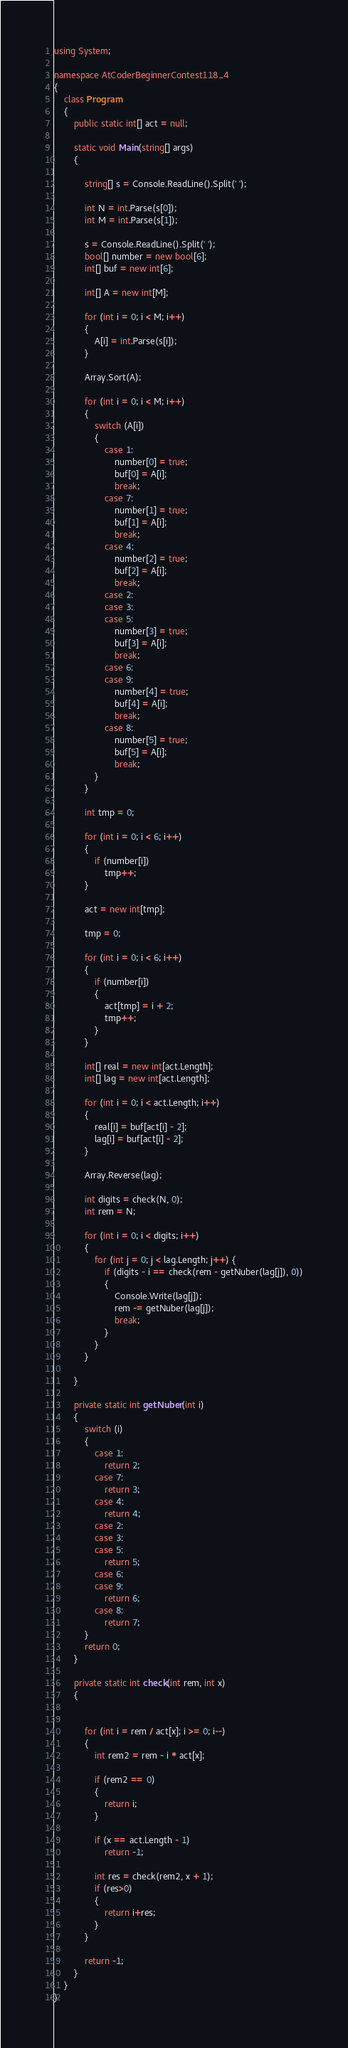<code> <loc_0><loc_0><loc_500><loc_500><_C#_>using System;

namespace AtCoderBeginnerContest118_4
{
    class Program
    {
        public static int[] act = null;

        static void Main(string[] args)
        {

            string[] s = Console.ReadLine().Split(' ');

            int N = int.Parse(s[0]);
            int M = int.Parse(s[1]);

            s = Console.ReadLine().Split(' ');
            bool[] number = new bool[6];
            int[] buf = new int[6];

            int[] A = new int[M];

            for (int i = 0; i < M; i++)
            {
                A[i] = int.Parse(s[i]);
            }

            Array.Sort(A);

            for (int i = 0; i < M; i++)
            {
                switch (A[i])
                {
                    case 1:
                        number[0] = true;
                        buf[0] = A[i];
                        break;
                    case 7:
                        number[1] = true;
                        buf[1] = A[i];
                        break;
                    case 4:
                        number[2] = true;
                        buf[2] = A[i];
                        break;
                    case 2:
                    case 3:
                    case 5:
                        number[3] = true;
                        buf[3] = A[i];
                        break;
                    case 6:
                    case 9:
                        number[4] = true;
                        buf[4] = A[i];
                        break;
                    case 8:
                        number[5] = true;
                        buf[5] = A[i];
                        break;
                }
            }

            int tmp = 0;

            for (int i = 0; i < 6; i++)
            {
                if (number[i])
                    tmp++;
            }

            act = new int[tmp];

            tmp = 0;

            for (int i = 0; i < 6; i++)
            {
                if (number[i])
                {
                    act[tmp] = i + 2;
                    tmp++;
                }
            }

            int[] real = new int[act.Length];
            int[] lag = new int[act.Length];

            for (int i = 0; i < act.Length; i++)
            {
                real[i] = buf[act[i] - 2];
                lag[i] = buf[act[i] - 2];
            }

            Array.Reverse(lag);

            int digits = check(N, 0);
            int rem = N;

            for (int i = 0; i < digits; i++)
            {
                for (int j = 0; j < lag.Length; j++) {
                    if (digits - i == check(rem - getNuber(lag[j]), 0))
                    {
                        Console.Write(lag[j]);
                        rem -= getNuber(lag[j]);
                        break;
                    }
                }
            }
                        
        }

        private static int getNuber(int i)
        {
            switch (i)
            {
                case 1:
                    return 2;
                case 7:
                    return 3;
                case 4:
                    return 4;
                case 2:
                case 3:
                case 5:
                    return 5;
                case 6:
                case 9:
                    return 6;
                case 8:
                    return 7;
            }
            return 0;
        }

        private static int check(int rem, int x)
        {


            for (int i = rem / act[x]; i >= 0; i--)
            {
                int rem2 = rem - i * act[x];

                if (rem2 == 0)
                {
                    return i;
                }

                if (x == act.Length - 1)
                    return -1;

                int res = check(rem2, x + 1);
                if (res>0)
                {
                    return i+res;
                }
            }

            return -1;
        }
    }
}
</code> 